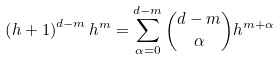Convert formula to latex. <formula><loc_0><loc_0><loc_500><loc_500>\left ( h + 1 \right ) ^ { d - m } h ^ { m } = \sum _ { \alpha = 0 } ^ { d - m } { d - m \choose \alpha } h ^ { m + \alpha }</formula> 